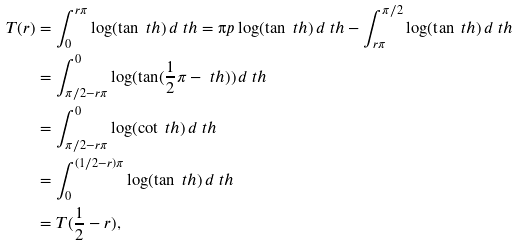<formula> <loc_0><loc_0><loc_500><loc_500>T ( r ) & = \int _ { 0 } ^ { r \pi } \log ( \tan \ t h ) \, d \ t h = \i p \log ( \tan \ t h ) \, d \ t h - \int _ { r \pi } ^ { \pi / 2 } \log ( \tan \ t h ) \, d \ t h \\ & = \int _ { \pi / 2 - r \pi } ^ { 0 } \log ( \tan ( \frac { 1 } { 2 } \pi - \ t h ) ) \, d \ t h \\ & = \int _ { \pi / 2 - r \pi } ^ { 0 } \log ( \cot \ t h ) \, d \ t h \\ & = \int _ { 0 } ^ { ( 1 / 2 - r ) \pi } \log ( \tan \ t h ) \, d \ t h \\ & = T ( \frac { 1 } { 2 } - r ) ,</formula> 